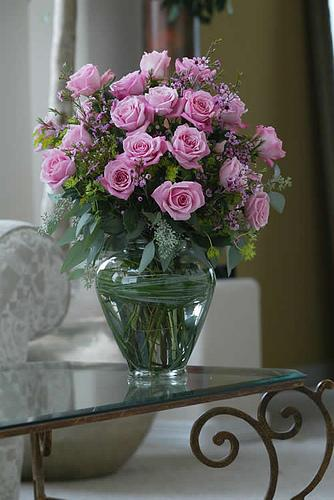Give a brief overview of the scene in the image, mentioning the main elements. The scene features a stunning floral arrangement in a clear vase, a glass coffee table with ornate metal legs, and a white designer chair. How would you describe the style of the chair visible in the image? The chair features an elegant white pattern on the arm and has a sophisticated, designer appearance. What is the interesting characteristic of the table in the image? The table has a glass top that allows reflections to be seen, with fancy wrought iron curly q designs as legs. Describe the ambiance of the room depicted in the image. The room emanates a cozy and elegant atmosphere, featuring a stylish glass table, picturesque floral arrangement, and chic white furniture. What is the most unusual aspect of the vase in the image? The vase is remarkably wide and round, with a transparency that highlights the beauty of the flowers within. In the image, what is the most striking quality of the floral arrangement? The most striking quality of the floral arrangement is the diverse mixture of pink roses and lavender flowers. Provide an artistic description of the primary object in the image. A captivating bouquet of pink roses and lavender flowers are gracefully resting in a wide, clear glass vase on the table. 